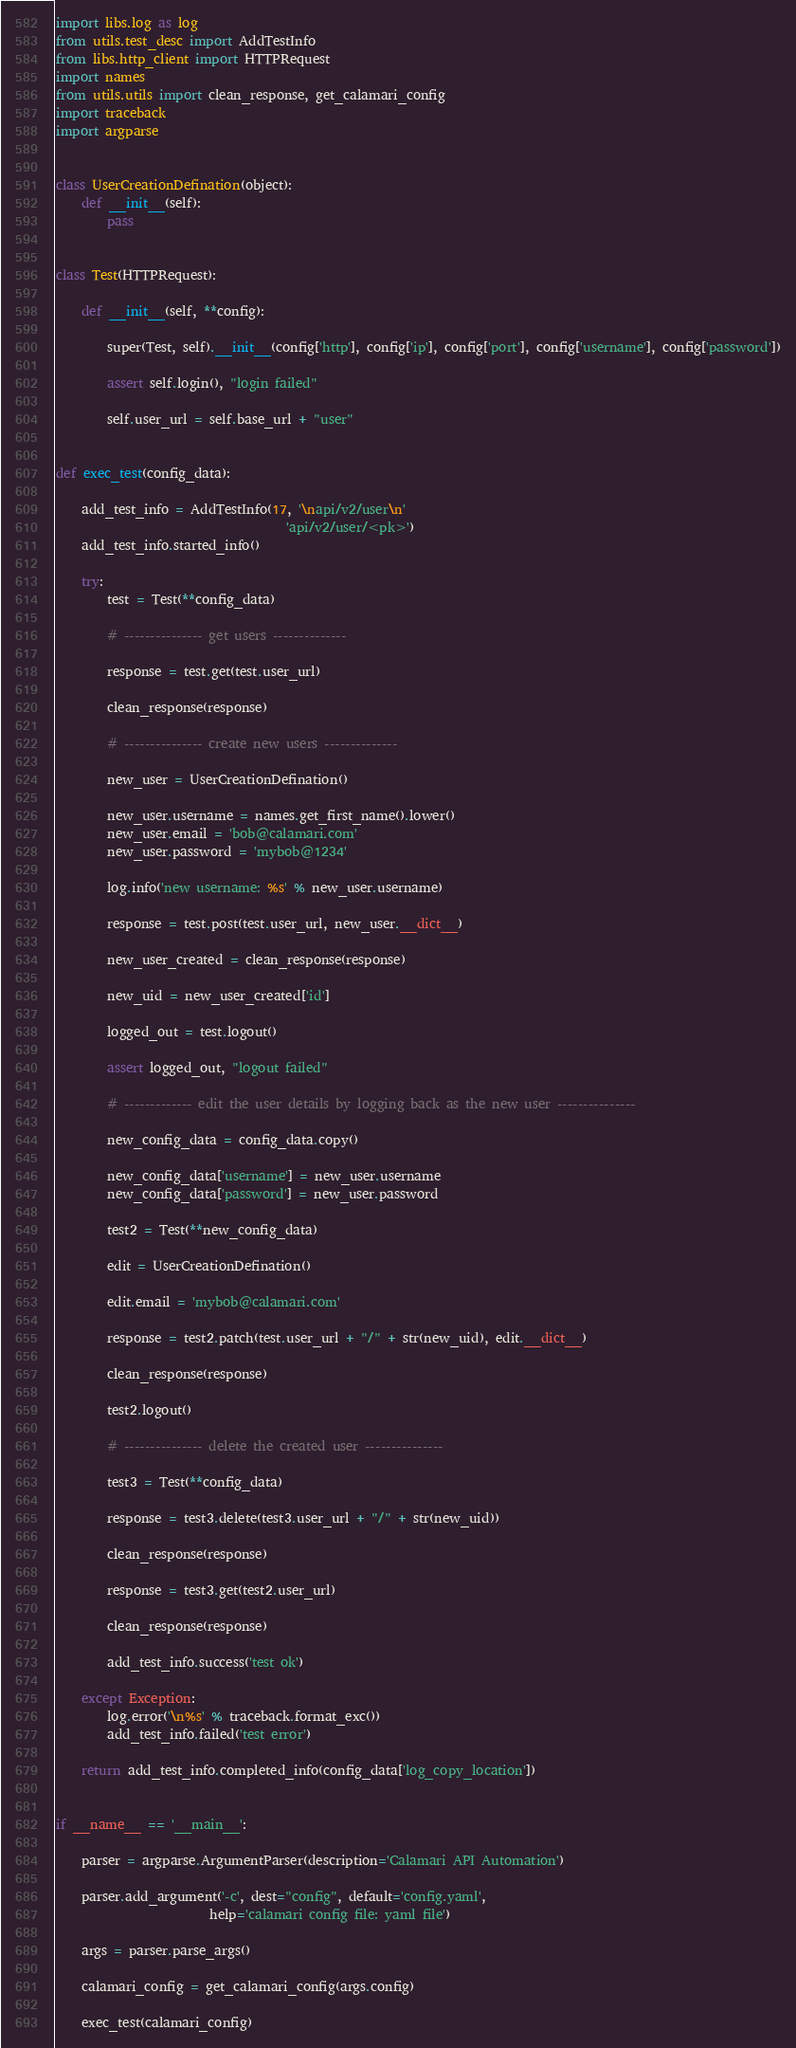Convert code to text. <code><loc_0><loc_0><loc_500><loc_500><_Python_>import libs.log as log
from utils.test_desc import AddTestInfo
from libs.http_client import HTTPRequest
import names
from utils.utils import clean_response, get_calamari_config
import traceback
import argparse


class UserCreationDefination(object):
    def __init__(self):
        pass


class Test(HTTPRequest):

    def __init__(self, **config):

        super(Test, self).__init__(config['http'], config['ip'], config['port'], config['username'], config['password'])

        assert self.login(), "login failed"

        self.user_url = self.base_url + "user"


def exec_test(config_data):

    add_test_info = AddTestInfo(17, '\napi/v2/user\n'
                                    'api/v2/user/<pk>')
    add_test_info.started_info()

    try:
        test = Test(**config_data)

        # --------------- get users --------------

        response = test.get(test.user_url)

        clean_response(response)

        # --------------- create new users --------------

        new_user = UserCreationDefination()

        new_user.username = names.get_first_name().lower()
        new_user.email = 'bob@calamari.com'
        new_user.password = 'mybob@1234'

        log.info('new username: %s' % new_user.username)

        response = test.post(test.user_url, new_user.__dict__)

        new_user_created = clean_response(response)

        new_uid = new_user_created['id']

        logged_out = test.logout()

        assert logged_out, "logout failed"

        # ------------- edit the user details by logging back as the new user ---------------

        new_config_data = config_data.copy()

        new_config_data['username'] = new_user.username
        new_config_data['password'] = new_user.password

        test2 = Test(**new_config_data)

        edit = UserCreationDefination()

        edit.email = 'mybob@calamari.com'

        response = test2.patch(test.user_url + "/" + str(new_uid), edit.__dict__)

        clean_response(response)

        test2.logout()

        # --------------- delete the created user ---------------

        test3 = Test(**config_data)

        response = test3.delete(test3.user_url + "/" + str(new_uid))

        clean_response(response)

        response = test3.get(test2.user_url)

        clean_response(response)

        add_test_info.success('test ok')

    except Exception:
        log.error('\n%s' % traceback.format_exc())
        add_test_info.failed('test error')

    return add_test_info.completed_info(config_data['log_copy_location'])


if __name__ == '__main__':

    parser = argparse.ArgumentParser(description='Calamari API Automation')

    parser.add_argument('-c', dest="config", default='config.yaml',
                        help='calamari config file: yaml file')

    args = parser.parse_args()

    calamari_config = get_calamari_config(args.config)

    exec_test(calamari_config)
</code> 